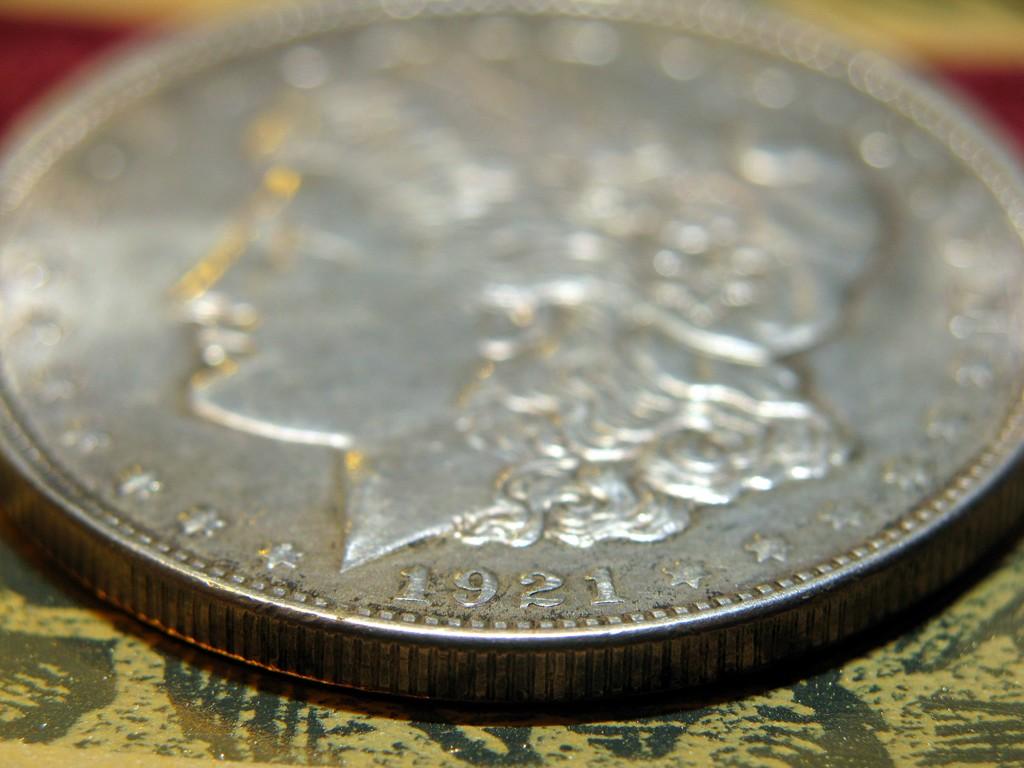What year is this coin minted?
Your response must be concise. 1921. What´s the number on the coin?
Provide a succinct answer. 1921. 